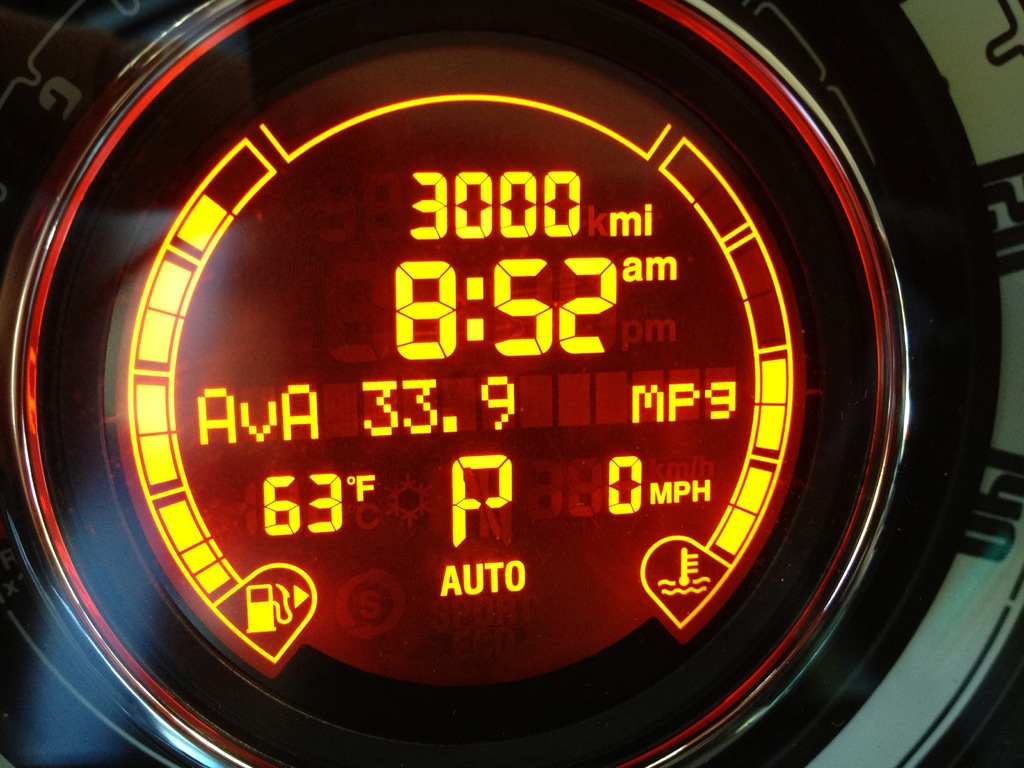What does the snowflake icon next to the temperature indicate? The snowflake icon next to the temperature reading of 67 degrees Fahrenheit suggests that the car has an external temperature sensor warning. This icon usually appears to alert the driver about potential icy conditions when the temperature nears freezing, although in this case, it's displayed due to the system's threshold settings. How might this information be useful to a driver? This information is crucial for driving safety. It warns the driver to be cautious of possible icy roads, which can reduce tire traction and increase the risk of accidents, especially in colder climates or unexpected weather changes. 